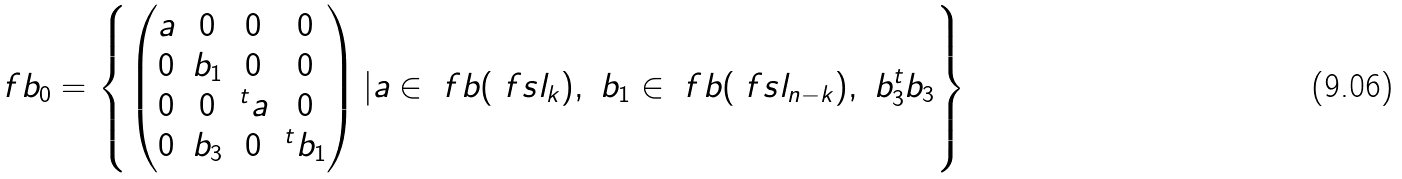<formula> <loc_0><loc_0><loc_500><loc_500>\ f b _ { 0 } = \left \{ \begin{pmatrix} a & 0 & 0 & 0 \\ 0 & b _ { 1 } & 0 & 0 \\ 0 & 0 & ^ { t } a & 0 \\ 0 & b _ { 3 } & 0 & ^ { t } b _ { 1 } \end{pmatrix} | a \in \ f b ( \ f s l _ { k } ) , \ b _ { 1 } \in \ f b ( \ f s l _ { n - k } ) , \ b _ { 3 } ^ { t } b _ { 3 } \right \}</formula> 